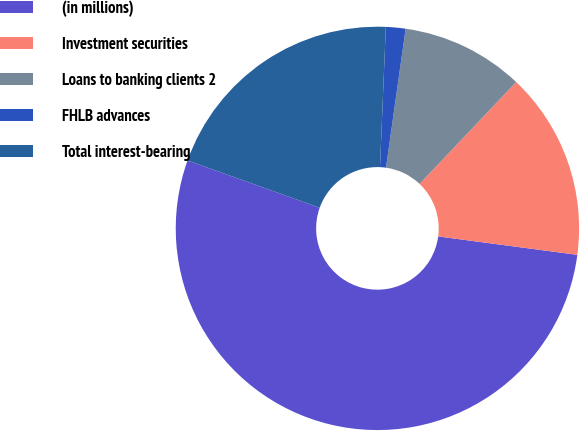<chart> <loc_0><loc_0><loc_500><loc_500><pie_chart><fcel>(in millions)<fcel>Investment securities<fcel>Loans to banking clients 2<fcel>FHLB advances<fcel>Total interest-bearing<nl><fcel>53.38%<fcel>15.02%<fcel>9.84%<fcel>1.57%<fcel>20.2%<nl></chart> 